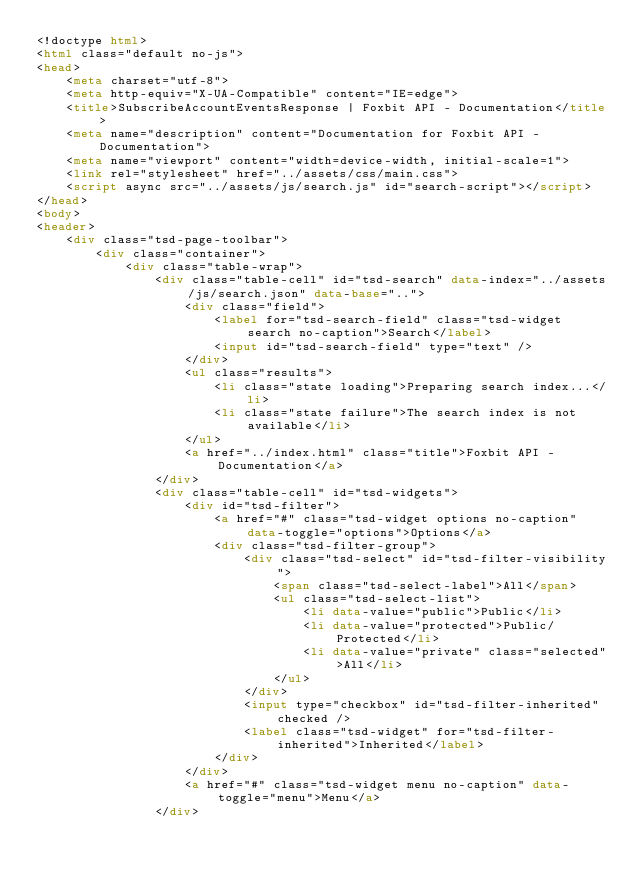Convert code to text. <code><loc_0><loc_0><loc_500><loc_500><_HTML_><!doctype html>
<html class="default no-js">
<head>
	<meta charset="utf-8">
	<meta http-equiv="X-UA-Compatible" content="IE=edge">
	<title>SubscribeAccountEventsResponse | Foxbit API - Documentation</title>
	<meta name="description" content="Documentation for Foxbit API - Documentation">
	<meta name="viewport" content="width=device-width, initial-scale=1">
	<link rel="stylesheet" href="../assets/css/main.css">
	<script async src="../assets/js/search.js" id="search-script"></script>
</head>
<body>
<header>
	<div class="tsd-page-toolbar">
		<div class="container">
			<div class="table-wrap">
				<div class="table-cell" id="tsd-search" data-index="../assets/js/search.json" data-base="..">
					<div class="field">
						<label for="tsd-search-field" class="tsd-widget search no-caption">Search</label>
						<input id="tsd-search-field" type="text" />
					</div>
					<ul class="results">
						<li class="state loading">Preparing search index...</li>
						<li class="state failure">The search index is not available</li>
					</ul>
					<a href="../index.html" class="title">Foxbit API - Documentation</a>
				</div>
				<div class="table-cell" id="tsd-widgets">
					<div id="tsd-filter">
						<a href="#" class="tsd-widget options no-caption" data-toggle="options">Options</a>
						<div class="tsd-filter-group">
							<div class="tsd-select" id="tsd-filter-visibility">
								<span class="tsd-select-label">All</span>
								<ul class="tsd-select-list">
									<li data-value="public">Public</li>
									<li data-value="protected">Public/Protected</li>
									<li data-value="private" class="selected">All</li>
								</ul>
							</div>
							<input type="checkbox" id="tsd-filter-inherited" checked />
							<label class="tsd-widget" for="tsd-filter-inherited">Inherited</label>
						</div>
					</div>
					<a href="#" class="tsd-widget menu no-caption" data-toggle="menu">Menu</a>
				</div></code> 